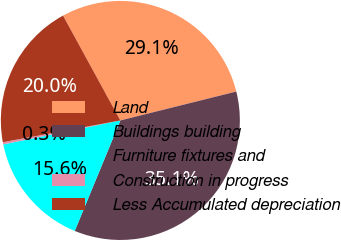Convert chart to OTSL. <chart><loc_0><loc_0><loc_500><loc_500><pie_chart><fcel>Land<fcel>Buildings building<fcel>Furniture fixtures and<fcel>Construction in progress<fcel>Less Accumulated depreciation<nl><fcel>29.07%<fcel>35.12%<fcel>15.56%<fcel>0.3%<fcel>19.95%<nl></chart> 